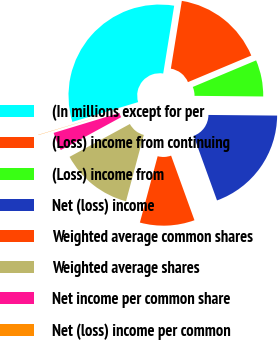<chart> <loc_0><loc_0><loc_500><loc_500><pie_chart><fcel>(In millions except for per<fcel>(Loss) income from continuing<fcel>(Loss) income from<fcel>Net (loss) income<fcel>Weighted average common shares<fcel>Weighted average shares<fcel>Net income per common share<fcel>Net (loss) income per common<nl><fcel>32.2%<fcel>16.12%<fcel>6.47%<fcel>19.33%<fcel>9.69%<fcel>12.9%<fcel>3.25%<fcel>0.04%<nl></chart> 